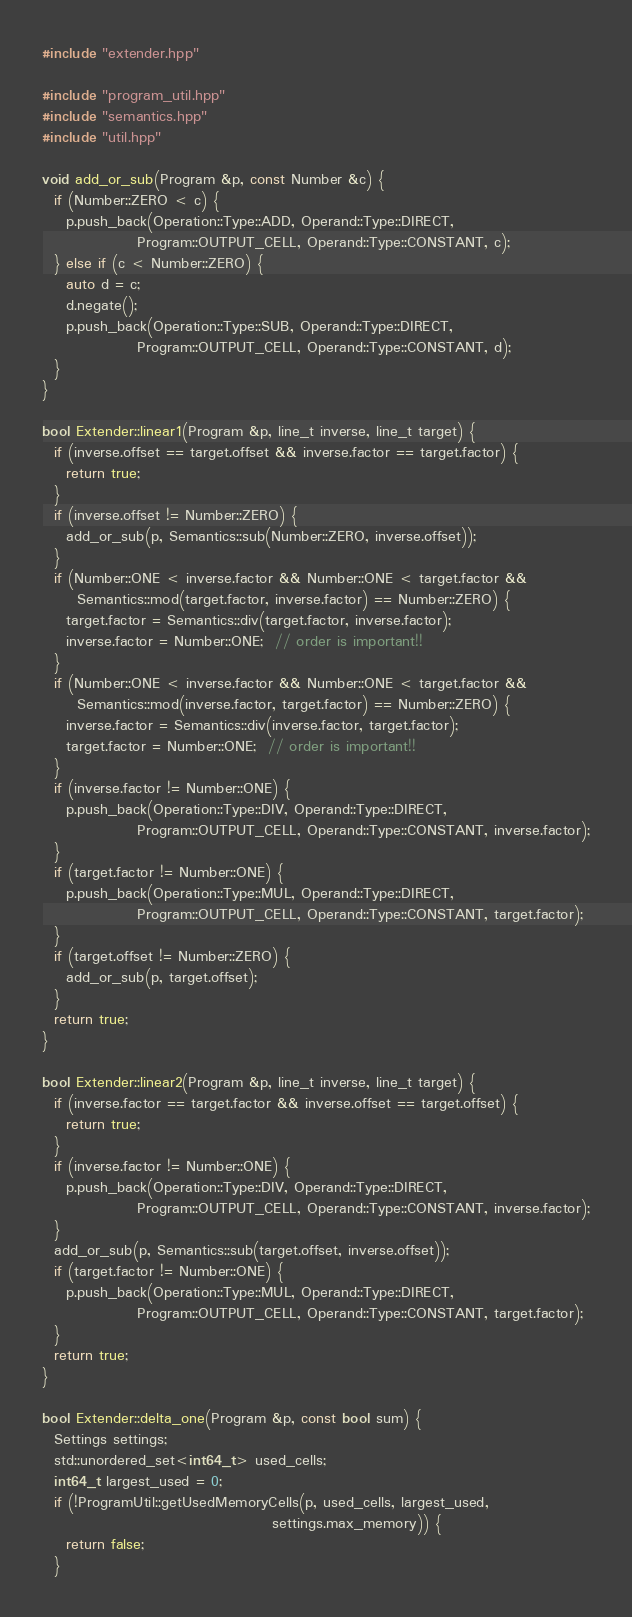<code> <loc_0><loc_0><loc_500><loc_500><_C++_>#include "extender.hpp"

#include "program_util.hpp"
#include "semantics.hpp"
#include "util.hpp"

void add_or_sub(Program &p, const Number &c) {
  if (Number::ZERO < c) {
    p.push_back(Operation::Type::ADD, Operand::Type::DIRECT,
                Program::OUTPUT_CELL, Operand::Type::CONSTANT, c);
  } else if (c < Number::ZERO) {
    auto d = c;
    d.negate();
    p.push_back(Operation::Type::SUB, Operand::Type::DIRECT,
                Program::OUTPUT_CELL, Operand::Type::CONSTANT, d);
  }
}

bool Extender::linear1(Program &p, line_t inverse, line_t target) {
  if (inverse.offset == target.offset && inverse.factor == target.factor) {
    return true;
  }
  if (inverse.offset != Number::ZERO) {
    add_or_sub(p, Semantics::sub(Number::ZERO, inverse.offset));
  }
  if (Number::ONE < inverse.factor && Number::ONE < target.factor &&
      Semantics::mod(target.factor, inverse.factor) == Number::ZERO) {
    target.factor = Semantics::div(target.factor, inverse.factor);
    inverse.factor = Number::ONE;  // order is important!!
  }
  if (Number::ONE < inverse.factor && Number::ONE < target.factor &&
      Semantics::mod(inverse.factor, target.factor) == Number::ZERO) {
    inverse.factor = Semantics::div(inverse.factor, target.factor);
    target.factor = Number::ONE;  // order is important!!
  }
  if (inverse.factor != Number::ONE) {
    p.push_back(Operation::Type::DIV, Operand::Type::DIRECT,
                Program::OUTPUT_CELL, Operand::Type::CONSTANT, inverse.factor);
  }
  if (target.factor != Number::ONE) {
    p.push_back(Operation::Type::MUL, Operand::Type::DIRECT,
                Program::OUTPUT_CELL, Operand::Type::CONSTANT, target.factor);
  }
  if (target.offset != Number::ZERO) {
    add_or_sub(p, target.offset);
  }
  return true;
}

bool Extender::linear2(Program &p, line_t inverse, line_t target) {
  if (inverse.factor == target.factor && inverse.offset == target.offset) {
    return true;
  }
  if (inverse.factor != Number::ONE) {
    p.push_back(Operation::Type::DIV, Operand::Type::DIRECT,
                Program::OUTPUT_CELL, Operand::Type::CONSTANT, inverse.factor);
  }
  add_or_sub(p, Semantics::sub(target.offset, inverse.offset));
  if (target.factor != Number::ONE) {
    p.push_back(Operation::Type::MUL, Operand::Type::DIRECT,
                Program::OUTPUT_CELL, Operand::Type::CONSTANT, target.factor);
  }
  return true;
}

bool Extender::delta_one(Program &p, const bool sum) {
  Settings settings;
  std::unordered_set<int64_t> used_cells;
  int64_t largest_used = 0;
  if (!ProgramUtil::getUsedMemoryCells(p, used_cells, largest_used,
                                       settings.max_memory)) {
    return false;
  }</code> 